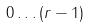Convert formula to latex. <formula><loc_0><loc_0><loc_500><loc_500>0 \dots ( r - 1 )</formula> 